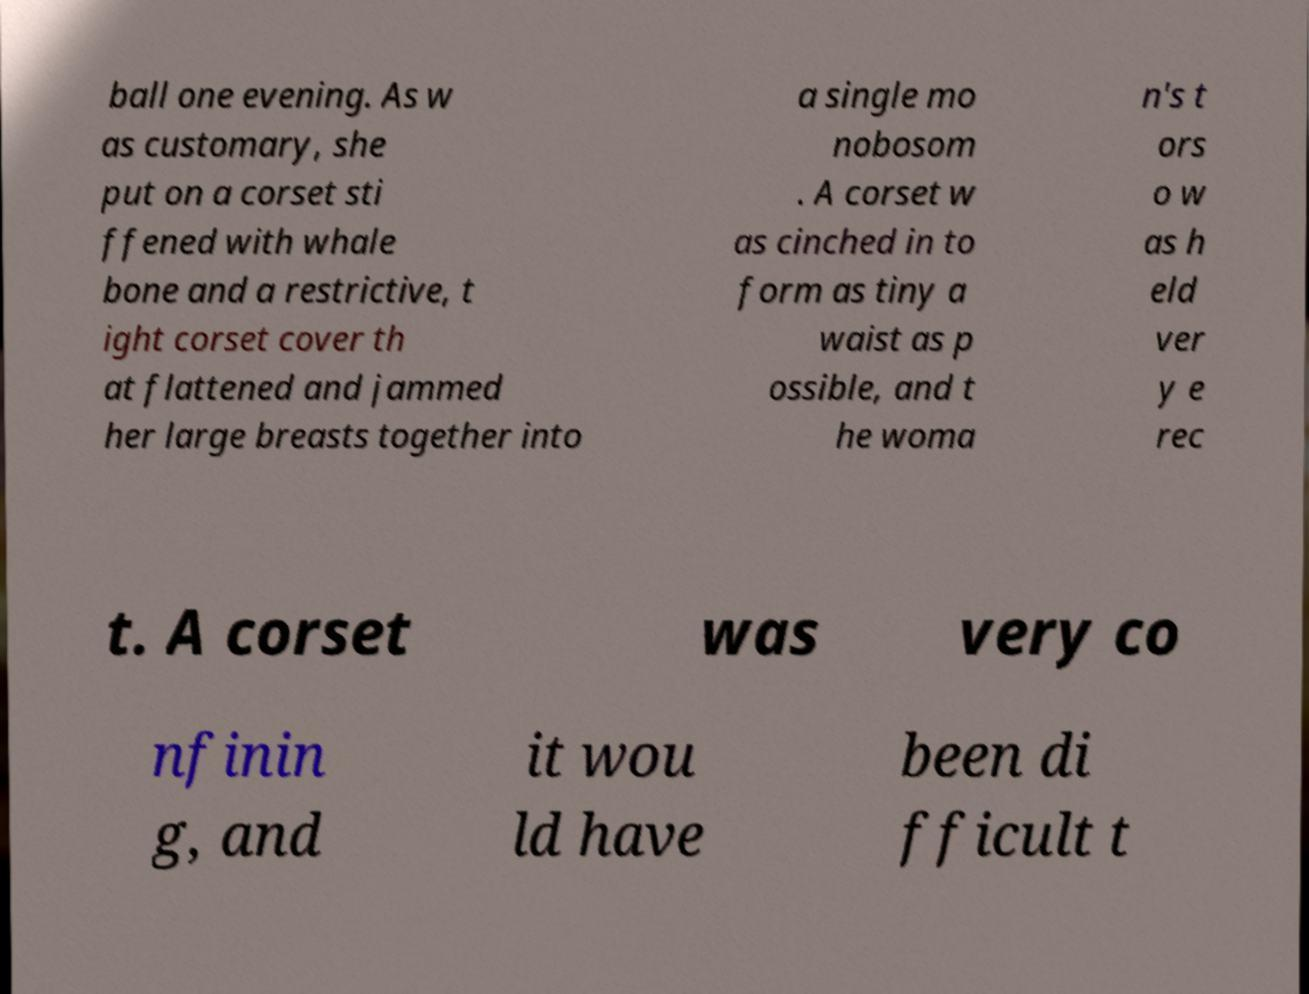I need the written content from this picture converted into text. Can you do that? ball one evening. As w as customary, she put on a corset sti ffened with whale bone and a restrictive, t ight corset cover th at flattened and jammed her large breasts together into a single mo nobosom . A corset w as cinched in to form as tiny a waist as p ossible, and t he woma n's t ors o w as h eld ver y e rec t. A corset was very co nfinin g, and it wou ld have been di fficult t 